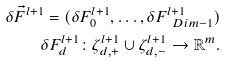Convert formula to latex. <formula><loc_0><loc_0><loc_500><loc_500>\delta \vec { F } ^ { l + 1 } = ( \delta F ^ { l + 1 } _ { 0 } , \dots , \delta F ^ { l + 1 } _ { \ D i m - 1 } ) \\ \delta F ^ { l + 1 } _ { d } \colon { \zeta } ^ { l + 1 } _ { d , + } \cup { \zeta } ^ { l + 1 } _ { d , - } \rightarrow { \mathbb { R } } ^ { m } .</formula> 